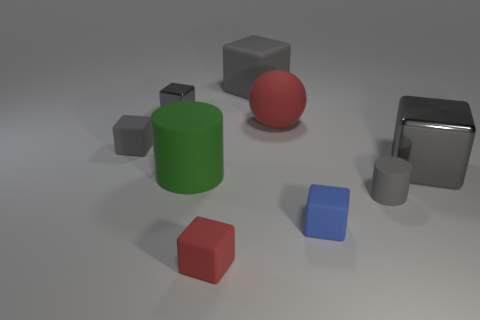There is a rubber thing that is the same color as the ball; what size is it?
Keep it short and to the point. Small. Is the number of small blue blocks less than the number of gray matte blocks?
Make the answer very short. Yes. What size is the other cylinder that is the same material as the small gray cylinder?
Provide a succinct answer. Large. What is the size of the green cylinder?
Your answer should be very brief. Large. What shape is the green rubber thing?
Your answer should be compact. Cylinder. Does the large rubber cylinder to the left of the tiny blue matte cube have the same color as the small shiny object?
Your answer should be compact. No. What is the size of the other object that is the same shape as the green object?
Make the answer very short. Small. Are there any other things that have the same material as the big red sphere?
Provide a short and direct response. Yes. There is a big cube in front of the gray metal block that is behind the large shiny block; is there a red rubber block that is behind it?
Keep it short and to the point. No. What is the small gray thing that is in front of the green thing made of?
Offer a terse response. Rubber. 